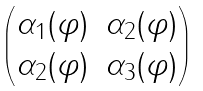Convert formula to latex. <formula><loc_0><loc_0><loc_500><loc_500>\begin{pmatrix} \alpha _ { 1 } ( \varphi ) & \alpha _ { 2 } ( \varphi ) \\ \alpha _ { 2 } ( \varphi ) & \alpha _ { 3 } ( \varphi ) \end{pmatrix}</formula> 